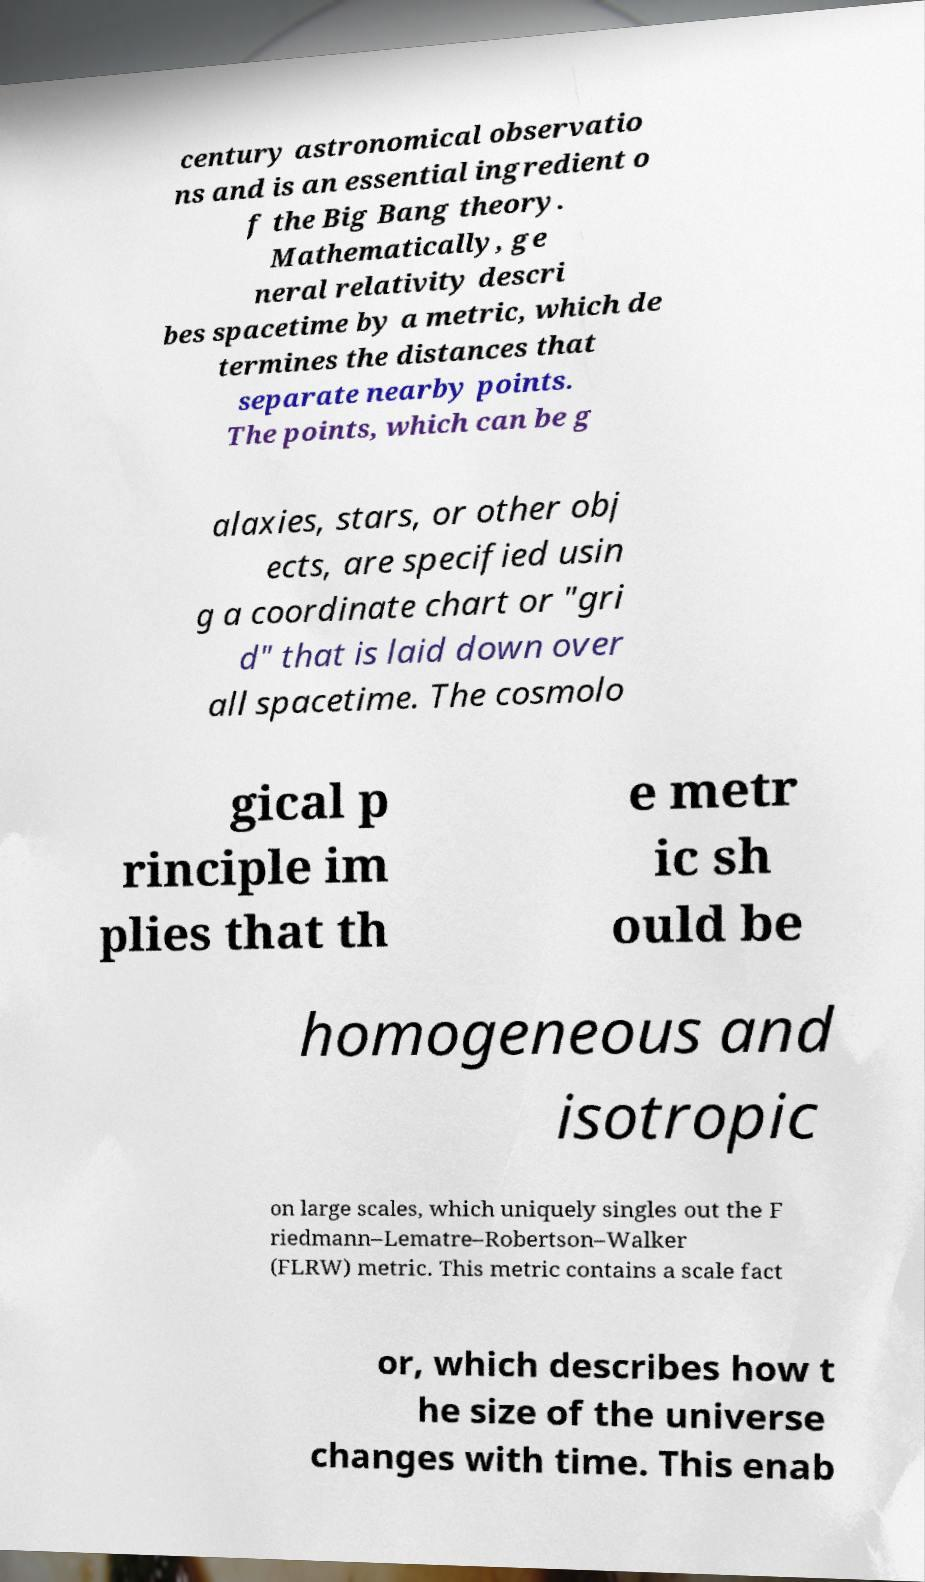There's text embedded in this image that I need extracted. Can you transcribe it verbatim? century astronomical observatio ns and is an essential ingredient o f the Big Bang theory. Mathematically, ge neral relativity descri bes spacetime by a metric, which de termines the distances that separate nearby points. The points, which can be g alaxies, stars, or other obj ects, are specified usin g a coordinate chart or "gri d" that is laid down over all spacetime. The cosmolo gical p rinciple im plies that th e metr ic sh ould be homogeneous and isotropic on large scales, which uniquely singles out the F riedmann–Lematre–Robertson–Walker (FLRW) metric. This metric contains a scale fact or, which describes how t he size of the universe changes with time. This enab 